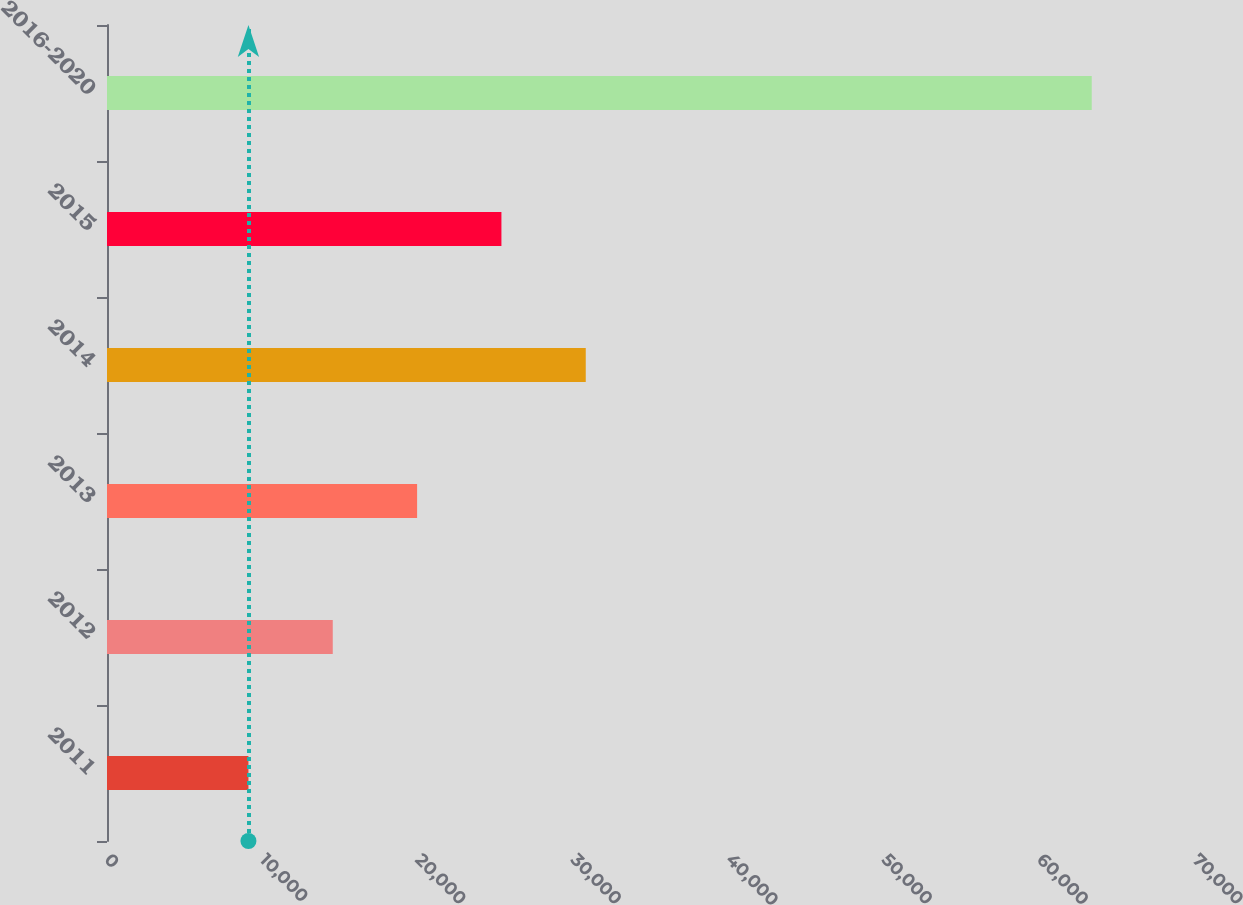Convert chart to OTSL. <chart><loc_0><loc_0><loc_500><loc_500><bar_chart><fcel>2011<fcel>2012<fcel>2013<fcel>2014<fcel>2015<fcel>2016-2020<nl><fcel>9100<fcel>14525.6<fcel>19951.2<fcel>30802.4<fcel>25376.8<fcel>63356<nl></chart> 